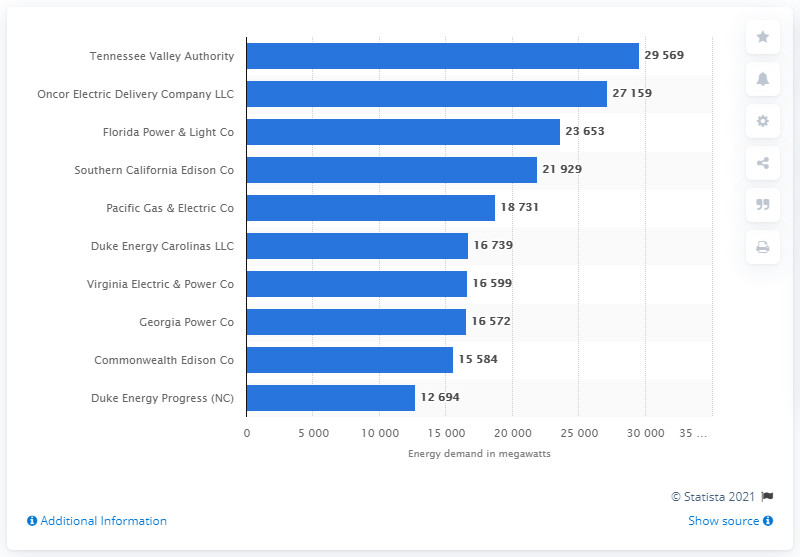List a handful of essential elements in this visual. In 2019, the Tennessee Valley Authority was the leading U.S. utility company in terms of summer peak electricity demand. In 2019, Oncor Electric Delivery Company LLC was the leading U.S. utility company in terms of summer peak electricity demand. 